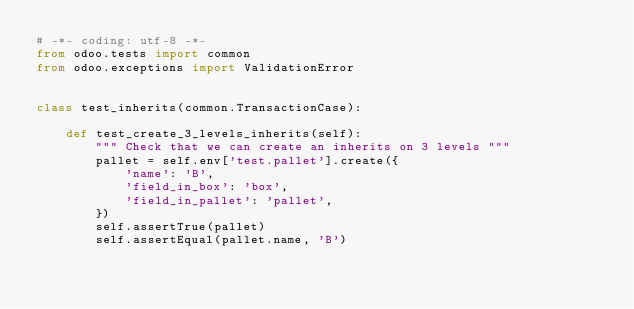Convert code to text. <code><loc_0><loc_0><loc_500><loc_500><_Python_># -*- coding: utf-8 -*-
from odoo.tests import common
from odoo.exceptions import ValidationError


class test_inherits(common.TransactionCase):

    def test_create_3_levels_inherits(self):
        """ Check that we can create an inherits on 3 levels """
        pallet = self.env['test.pallet'].create({
            'name': 'B',
            'field_in_box': 'box',
            'field_in_pallet': 'pallet',
        })
        self.assertTrue(pallet)
        self.assertEqual(pallet.name, 'B')</code> 